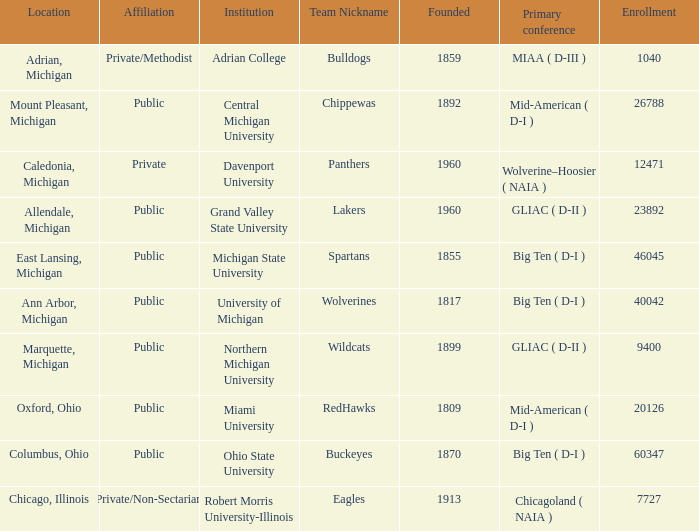What is the enrollment for the Redhawks? 1.0. 